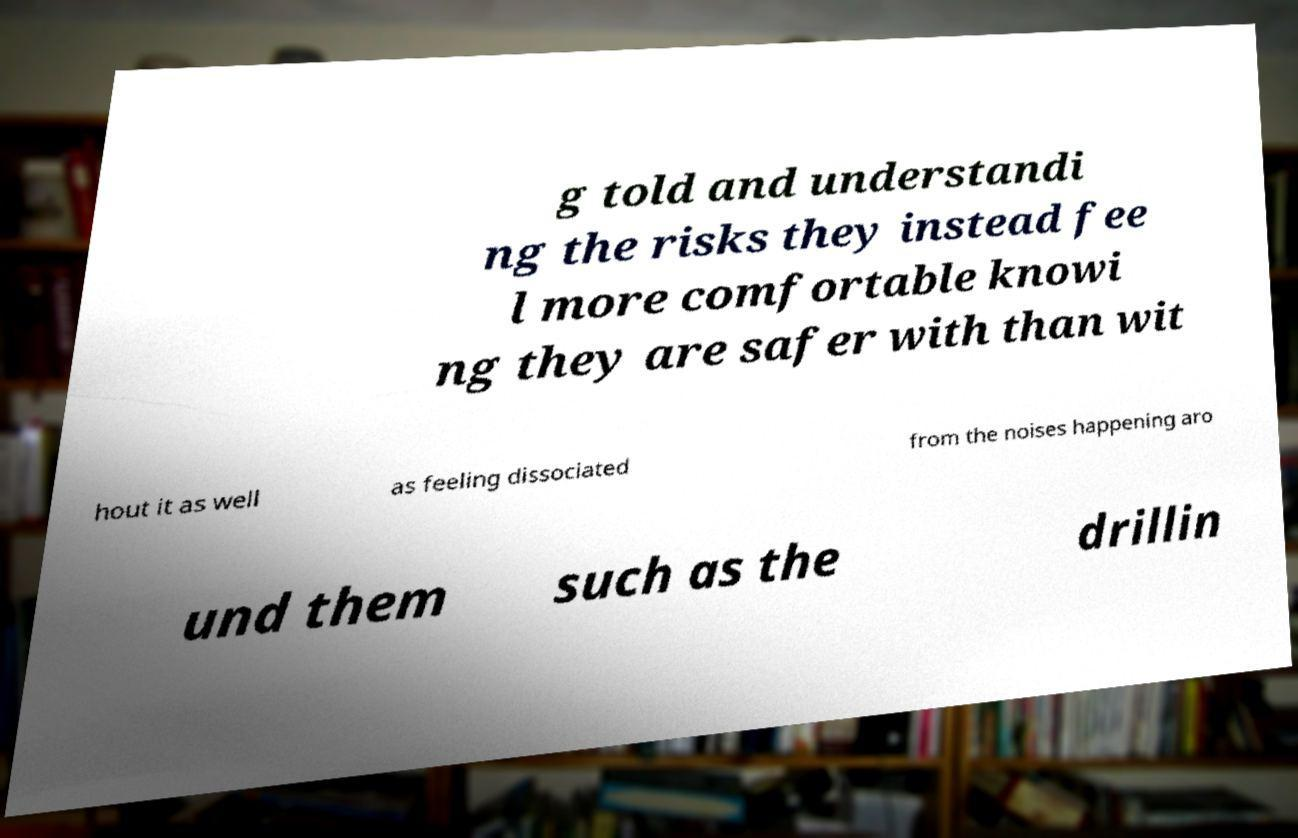Please read and relay the text visible in this image. What does it say? g told and understandi ng the risks they instead fee l more comfortable knowi ng they are safer with than wit hout it as well as feeling dissociated from the noises happening aro und them such as the drillin 